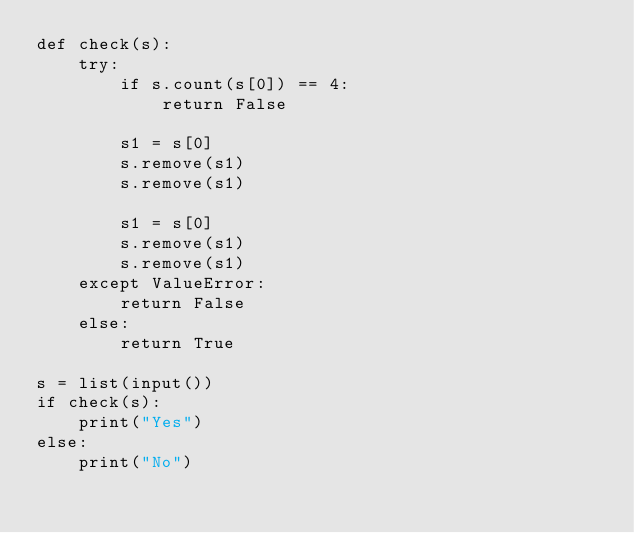<code> <loc_0><loc_0><loc_500><loc_500><_Python_>def check(s):
    try:
        if s.count(s[0]) == 4:
            return False

        s1 = s[0]
        s.remove(s1)
        s.remove(s1)

        s1 = s[0]
        s.remove(s1)
        s.remove(s1)
    except ValueError:
        return False
    else:
        return True

s = list(input())
if check(s):
    print("Yes")
else:
    print("No")</code> 